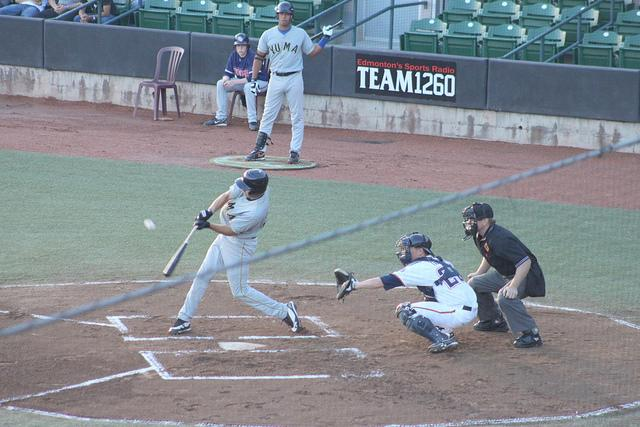What province is this located? alberta 